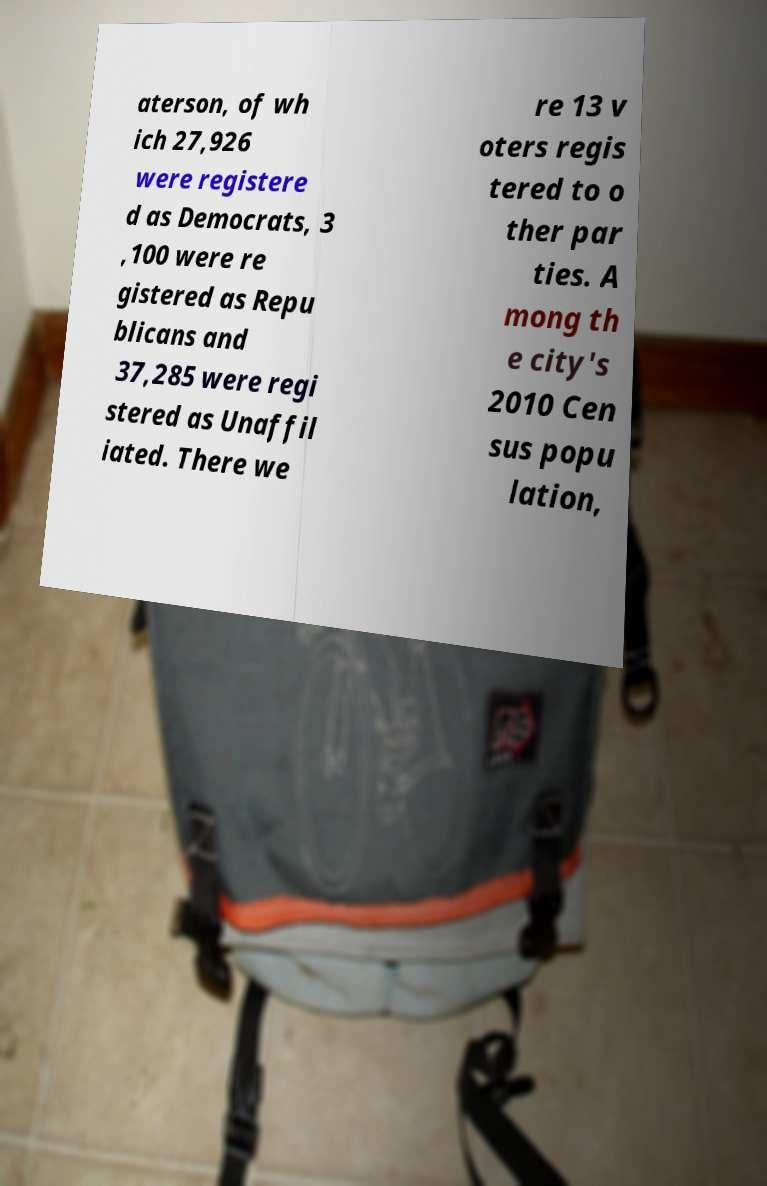Could you extract and type out the text from this image? aterson, of wh ich 27,926 were registere d as Democrats, 3 ,100 were re gistered as Repu blicans and 37,285 were regi stered as Unaffil iated. There we re 13 v oters regis tered to o ther par ties. A mong th e city's 2010 Cen sus popu lation, 